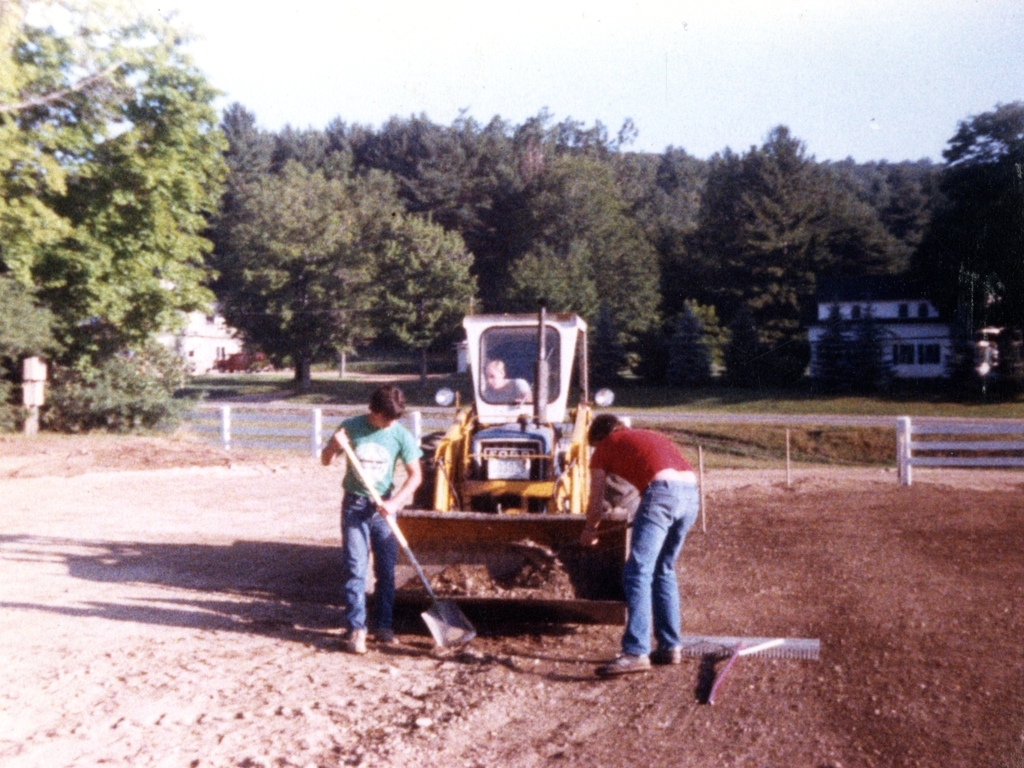Can you describe the environment in which these people are working? The people are working in an outdoor setting that appears rural or semi-rural. There are trees in the background and a couple of houses, which suggest a residential area. The ground is uneven with visible patches of grass, indicating that the site may be in the early stages of being leveled for construction or landscaping. Does the equipment look modern? The backhoe in the image has a design that suggests it is an older model. The equipment, along with the overall image quality and clothing style of the individuals, would indicate that this photo may have been taken several decades ago. 